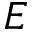Convert formula to latex. <formula><loc_0><loc_0><loc_500><loc_500>E</formula> 